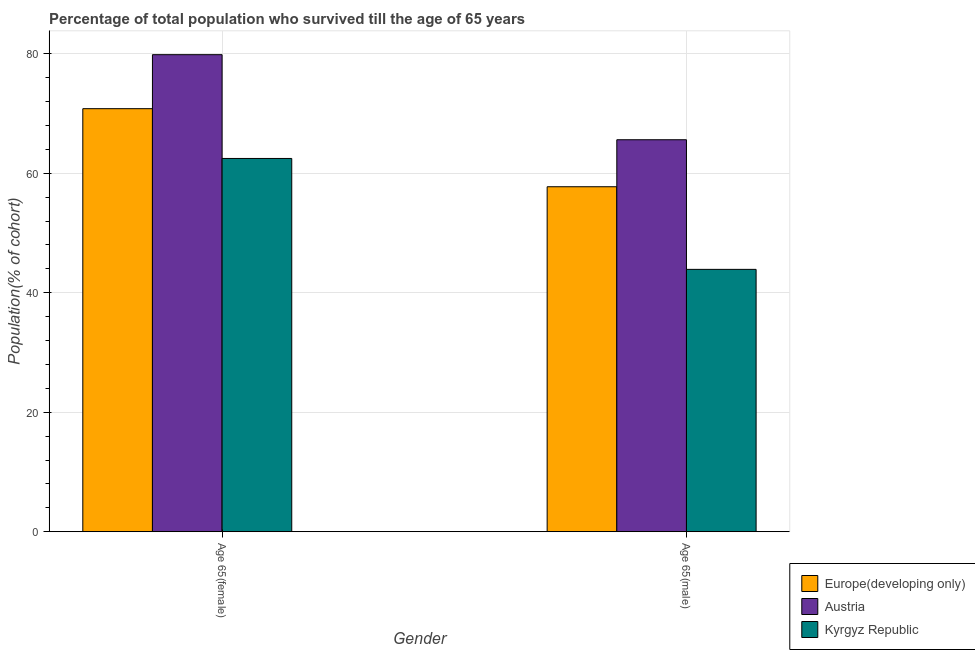Are the number of bars per tick equal to the number of legend labels?
Offer a terse response. Yes. How many bars are there on the 2nd tick from the right?
Your answer should be very brief. 3. What is the label of the 2nd group of bars from the left?
Ensure brevity in your answer.  Age 65(male). What is the percentage of female population who survived till age of 65 in Austria?
Your answer should be compact. 79.86. Across all countries, what is the maximum percentage of male population who survived till age of 65?
Your answer should be very brief. 65.62. Across all countries, what is the minimum percentage of female population who survived till age of 65?
Provide a succinct answer. 62.48. In which country was the percentage of female population who survived till age of 65 maximum?
Provide a short and direct response. Austria. In which country was the percentage of female population who survived till age of 65 minimum?
Offer a terse response. Kyrgyz Republic. What is the total percentage of male population who survived till age of 65 in the graph?
Give a very brief answer. 167.28. What is the difference between the percentage of female population who survived till age of 65 in Austria and that in Europe(developing only)?
Make the answer very short. 9.04. What is the difference between the percentage of male population who survived till age of 65 in Kyrgyz Republic and the percentage of female population who survived till age of 65 in Austria?
Give a very brief answer. -35.94. What is the average percentage of male population who survived till age of 65 per country?
Your response must be concise. 55.76. What is the difference between the percentage of male population who survived till age of 65 and percentage of female population who survived till age of 65 in Kyrgyz Republic?
Make the answer very short. -18.57. In how many countries, is the percentage of male population who survived till age of 65 greater than 32 %?
Offer a very short reply. 3. What is the ratio of the percentage of female population who survived till age of 65 in Austria to that in Europe(developing only)?
Make the answer very short. 1.13. Is the percentage of male population who survived till age of 65 in Kyrgyz Republic less than that in Austria?
Give a very brief answer. Yes. In how many countries, is the percentage of male population who survived till age of 65 greater than the average percentage of male population who survived till age of 65 taken over all countries?
Provide a short and direct response. 2. What does the 2nd bar from the left in Age 65(male) represents?
Keep it short and to the point. Austria. What does the 1st bar from the right in Age 65(male) represents?
Offer a very short reply. Kyrgyz Republic. What is the difference between two consecutive major ticks on the Y-axis?
Your answer should be compact. 20. Does the graph contain any zero values?
Provide a short and direct response. No. How many legend labels are there?
Your answer should be very brief. 3. How are the legend labels stacked?
Give a very brief answer. Vertical. What is the title of the graph?
Provide a short and direct response. Percentage of total population who survived till the age of 65 years. What is the label or title of the X-axis?
Keep it short and to the point. Gender. What is the label or title of the Y-axis?
Give a very brief answer. Population(% of cohort). What is the Population(% of cohort) of Europe(developing only) in Age 65(female)?
Ensure brevity in your answer.  70.82. What is the Population(% of cohort) of Austria in Age 65(female)?
Give a very brief answer. 79.86. What is the Population(% of cohort) in Kyrgyz Republic in Age 65(female)?
Keep it short and to the point. 62.48. What is the Population(% of cohort) of Europe(developing only) in Age 65(male)?
Make the answer very short. 57.75. What is the Population(% of cohort) of Austria in Age 65(male)?
Keep it short and to the point. 65.62. What is the Population(% of cohort) of Kyrgyz Republic in Age 65(male)?
Offer a terse response. 43.92. Across all Gender, what is the maximum Population(% of cohort) in Europe(developing only)?
Keep it short and to the point. 70.82. Across all Gender, what is the maximum Population(% of cohort) of Austria?
Provide a succinct answer. 79.86. Across all Gender, what is the maximum Population(% of cohort) in Kyrgyz Republic?
Your answer should be compact. 62.48. Across all Gender, what is the minimum Population(% of cohort) in Europe(developing only)?
Your answer should be compact. 57.75. Across all Gender, what is the minimum Population(% of cohort) of Austria?
Offer a very short reply. 65.62. Across all Gender, what is the minimum Population(% of cohort) in Kyrgyz Republic?
Provide a short and direct response. 43.92. What is the total Population(% of cohort) in Europe(developing only) in the graph?
Provide a succinct answer. 128.56. What is the total Population(% of cohort) in Austria in the graph?
Offer a very short reply. 145.47. What is the total Population(% of cohort) of Kyrgyz Republic in the graph?
Keep it short and to the point. 106.4. What is the difference between the Population(% of cohort) in Europe(developing only) in Age 65(female) and that in Age 65(male)?
Provide a succinct answer. 13.07. What is the difference between the Population(% of cohort) of Austria in Age 65(female) and that in Age 65(male)?
Ensure brevity in your answer.  14.24. What is the difference between the Population(% of cohort) of Kyrgyz Republic in Age 65(female) and that in Age 65(male)?
Your response must be concise. 18.57. What is the difference between the Population(% of cohort) in Europe(developing only) in Age 65(female) and the Population(% of cohort) in Austria in Age 65(male)?
Ensure brevity in your answer.  5.2. What is the difference between the Population(% of cohort) in Europe(developing only) in Age 65(female) and the Population(% of cohort) in Kyrgyz Republic in Age 65(male)?
Your response must be concise. 26.9. What is the difference between the Population(% of cohort) in Austria in Age 65(female) and the Population(% of cohort) in Kyrgyz Republic in Age 65(male)?
Ensure brevity in your answer.  35.94. What is the average Population(% of cohort) in Europe(developing only) per Gender?
Provide a short and direct response. 64.28. What is the average Population(% of cohort) in Austria per Gender?
Give a very brief answer. 72.74. What is the average Population(% of cohort) of Kyrgyz Republic per Gender?
Provide a short and direct response. 53.2. What is the difference between the Population(% of cohort) in Europe(developing only) and Population(% of cohort) in Austria in Age 65(female)?
Make the answer very short. -9.04. What is the difference between the Population(% of cohort) in Europe(developing only) and Population(% of cohort) in Kyrgyz Republic in Age 65(female)?
Your answer should be very brief. 8.33. What is the difference between the Population(% of cohort) of Austria and Population(% of cohort) of Kyrgyz Republic in Age 65(female)?
Offer a very short reply. 17.37. What is the difference between the Population(% of cohort) in Europe(developing only) and Population(% of cohort) in Austria in Age 65(male)?
Make the answer very short. -7.87. What is the difference between the Population(% of cohort) in Europe(developing only) and Population(% of cohort) in Kyrgyz Republic in Age 65(male)?
Keep it short and to the point. 13.83. What is the difference between the Population(% of cohort) of Austria and Population(% of cohort) of Kyrgyz Republic in Age 65(male)?
Keep it short and to the point. 21.7. What is the ratio of the Population(% of cohort) in Europe(developing only) in Age 65(female) to that in Age 65(male)?
Your answer should be very brief. 1.23. What is the ratio of the Population(% of cohort) in Austria in Age 65(female) to that in Age 65(male)?
Your answer should be compact. 1.22. What is the ratio of the Population(% of cohort) in Kyrgyz Republic in Age 65(female) to that in Age 65(male)?
Your response must be concise. 1.42. What is the difference between the highest and the second highest Population(% of cohort) of Europe(developing only)?
Offer a very short reply. 13.07. What is the difference between the highest and the second highest Population(% of cohort) of Austria?
Your response must be concise. 14.24. What is the difference between the highest and the second highest Population(% of cohort) of Kyrgyz Republic?
Give a very brief answer. 18.57. What is the difference between the highest and the lowest Population(% of cohort) of Europe(developing only)?
Offer a terse response. 13.07. What is the difference between the highest and the lowest Population(% of cohort) in Austria?
Ensure brevity in your answer.  14.24. What is the difference between the highest and the lowest Population(% of cohort) of Kyrgyz Republic?
Offer a terse response. 18.57. 